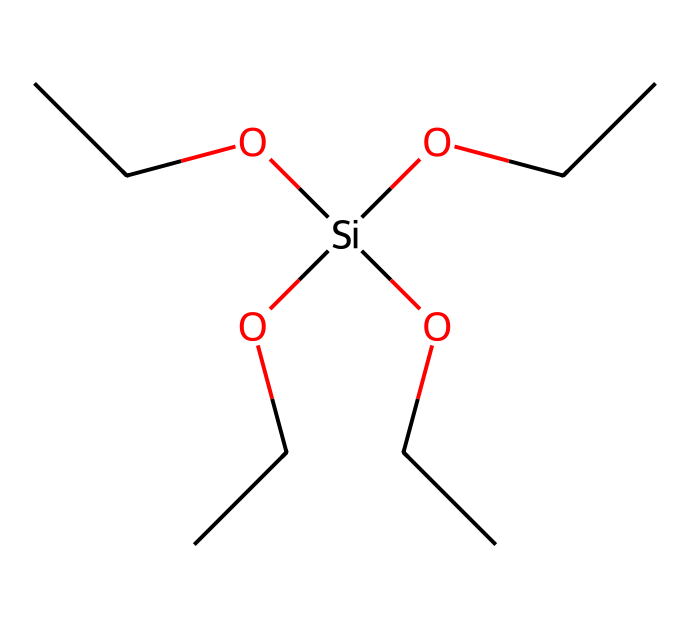How many ethyl groups are present in this chemical? The structure contains four ethyl groups, each represented as "CC" in the SMILES notation. There are four occurrences of "OCC" which indicates the presence of these groups.
Answer: four What is the central atom in the chemical structure? The central atom is silicon, represented by "Si" in the SMILES notation, indicating that it is the atom to which the ethyl groups and hydroxyls are attached.
Answer: silicon What type of bonds are present in this compound? The compound contains both single bonds (C-C and C-Si) and also bond types related to the functional groups, notably silicon-oxygen bonds (Si-O), all of which are represented in the structure.
Answer: single bonds How many hydroxyl groups (–OH) are present in the structure? In the SMILES, the "O" atoms followed by the ethyl groups represent the hydroxyl groups, and there are four such occurrences.
Answer: four What is the purpose of tetraethyl orthosilicate in semiconductor manufacturing? Tetraethyl orthosilicate (TEOS) acts as a precursor for silicon dioxide (SiO2) films in semiconductor production. Its structure allows it to undergo hydrolysis and condensation to form SiO2.
Answer: precursor What does the presence of the ethyl group indicate about the solubility properties of this compound? The ethyl groups enhance the solubility of the compound in organic solvents due to their hydrophobic nature, which can aid in its processing in semiconductor applications.
Answer: organic solubility How does the structure of tetraethyl orthosilicate relate to its reactivity? The structure allows for hydrolysis and condensation reactions, where the silicon atom can bond with oxygen from water, making it reactive and suitable for forming silica networks.
Answer: reactive 